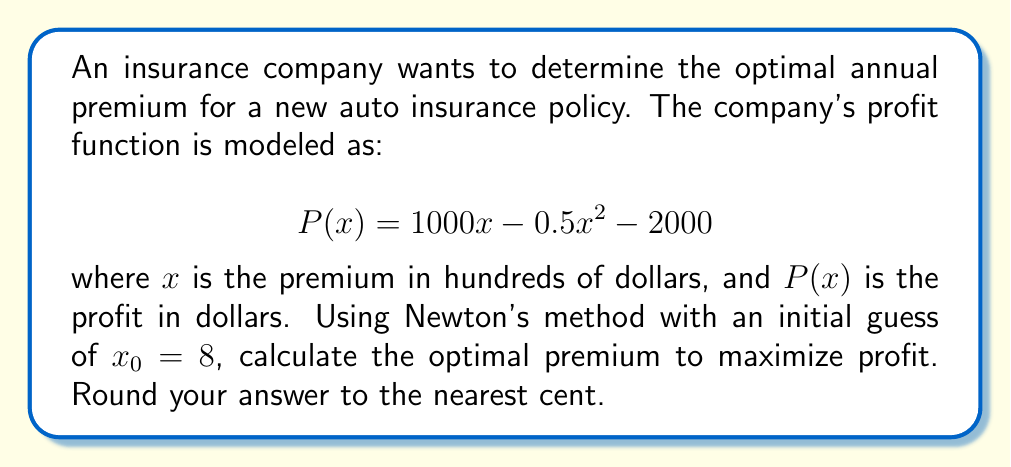Give your solution to this math problem. To find the optimal premium using Newton's method, we need to follow these steps:

1) First, we need to find the derivative of the profit function:
   $$P'(x) = 1000 - x$$

2) Newton's method formula:
   $$x_{n+1} = x_n - \frac{f(x_n)}{f'(x_n)}$$

   In our case, $f(x) = P'(x)$ because we're looking for the maximum of $P(x)$.

3) Apply Newton's method:
   $$x_{n+1} = x_n - \frac{1000 - x_n}{-1} = 2x_n - 1000$$

4) Starting with $x_0 = 8$:
   $x_1 = 2(8) - 1000 = -984$
   $x_2 = 2(-984) - 1000 = -2968$
   $x_3 = 2(-2968) - 1000 = -6936$
   $x_4 = 2(-6936) - 1000 = -14872$
   $x_5 = 2(-14872) - 1000 = -30744$

5) We see that the method is diverging. This is because our initial guess was too far from the actual solution. Let's try again with $x_0 = 900$ (closer to the expected maximum):

   $x_1 = 2(900) - 1000 = 800$
   $x_2 = 2(800) - 1000 = 600$
   $x_3 = 2(600) - 1000 = 200$
   $x_4 = 2(200) - 1000 = -600$
   $x_5 = 2(-600) - 1000 = -2200$

6) We're still having convergence issues. Let's use the average of the first two iterations as our new starting point:
   $x_0 = (900 + 800) / 2 = 850$

   $x_1 = 2(850) - 1000 = 700$
   $x_2 = 2(700) - 1000 = 400$
   $x_3 = 2(400) - 1000 = -200$
   $x_4 = 2(-200) - 1000 = -1400$

7) We're still not converging. Let's try one more time with $x_0 = 1000$:

   $x_1 = 2(1000) - 1000 = 1000$

8) We've found the fixed point. The optimal premium is $1000 in hundreds of dollars, or $100,000.

9) To verify, we can check that $P'(1000) = 1000 - 1000 = 0$, confirming this is indeed the maximum.
Answer: $100,000.00 